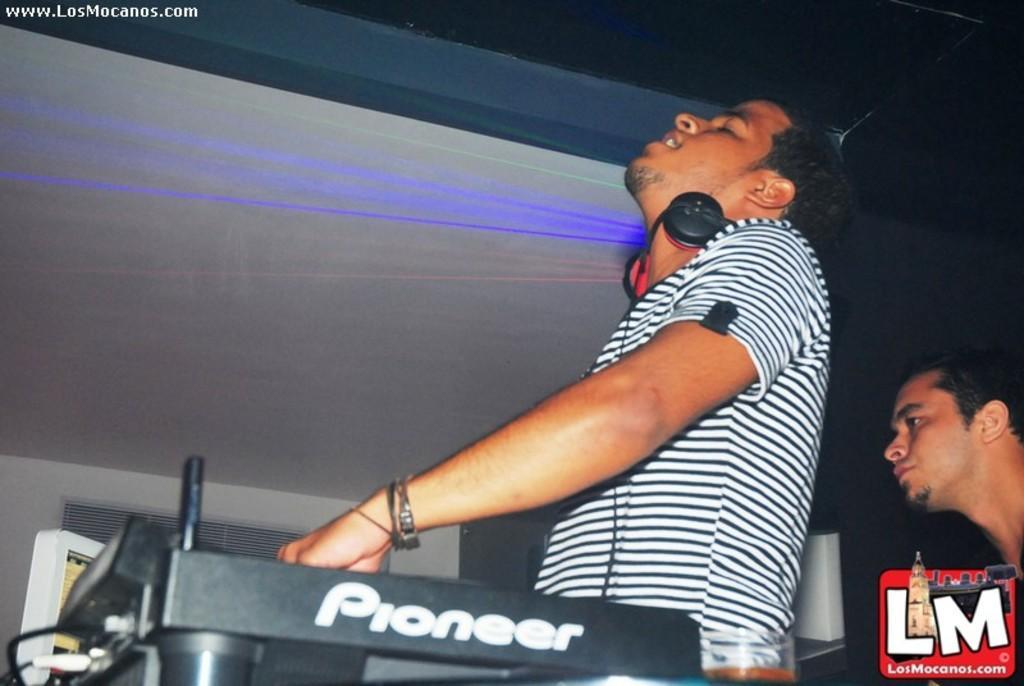Describe this image in one or two sentences. In this image I can see in the middle a man is adjusting the music system, he wore t-shirt. On the right side there is another man looking at that side 